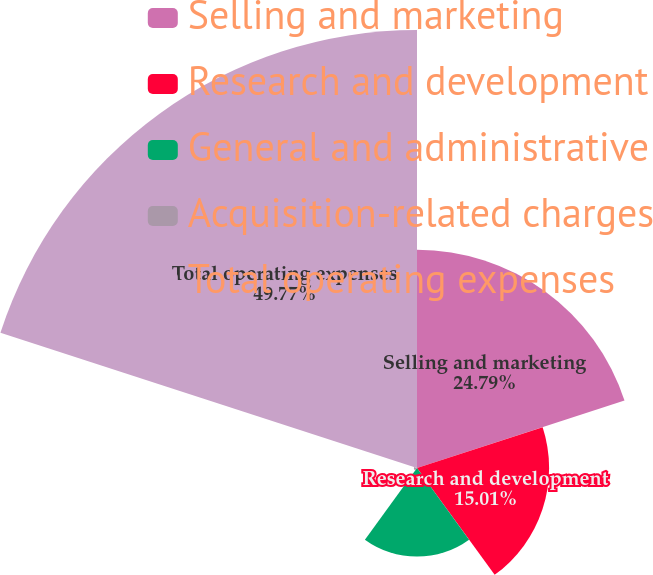Convert chart. <chart><loc_0><loc_0><loc_500><loc_500><pie_chart><fcel>Selling and marketing<fcel>Research and development<fcel>General and administrative<fcel>Acquisition-related charges<fcel>Total operating expenses<nl><fcel>24.79%<fcel>15.01%<fcel>10.07%<fcel>0.36%<fcel>49.77%<nl></chart> 